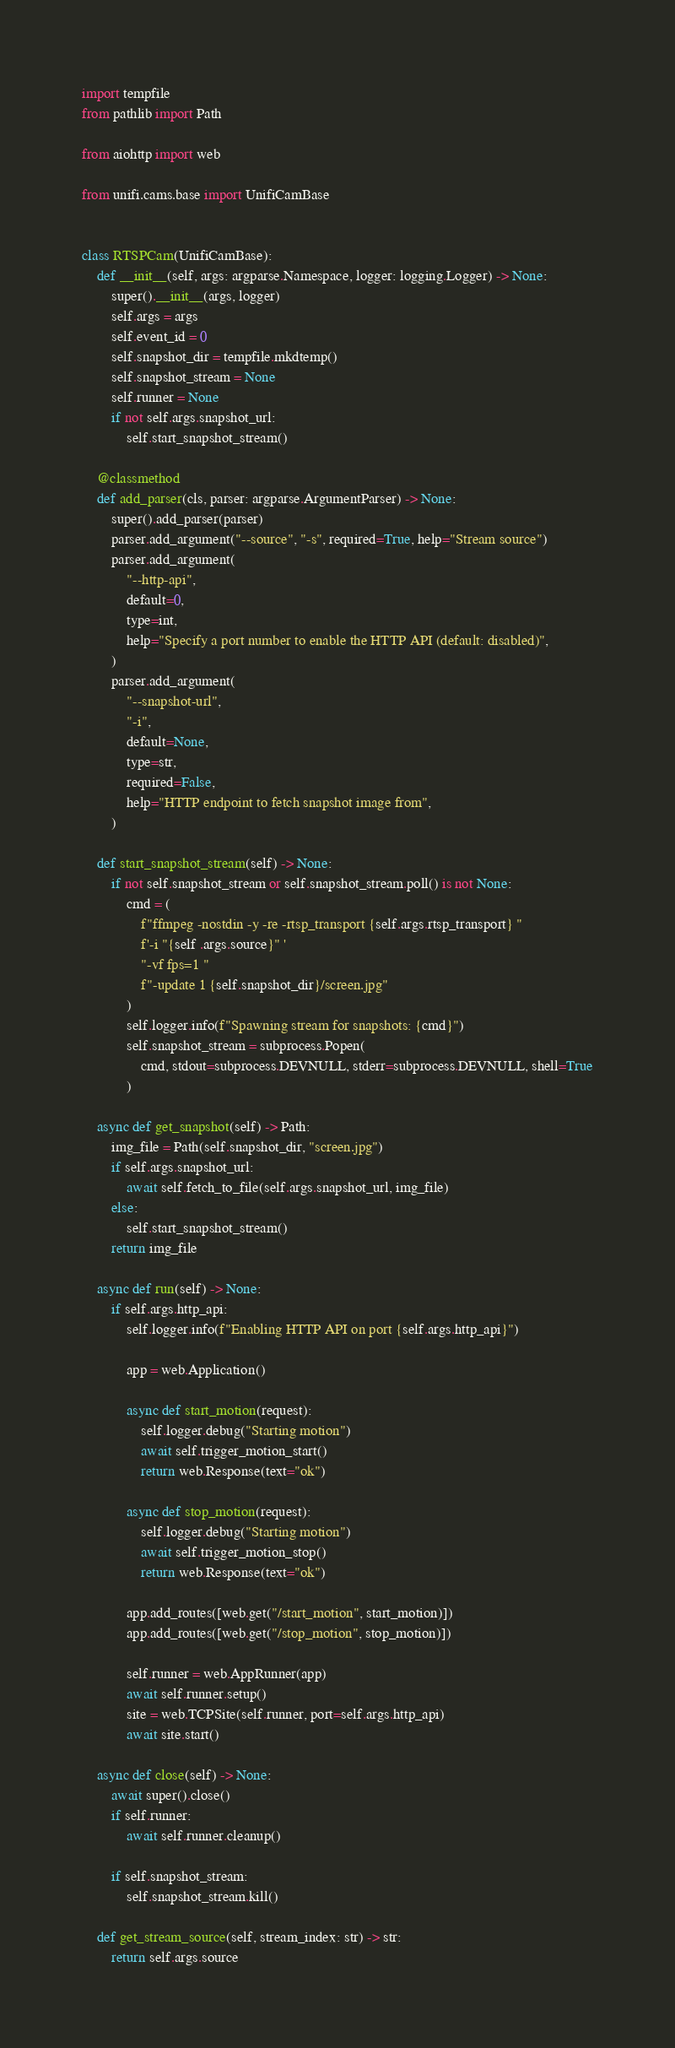Convert code to text. <code><loc_0><loc_0><loc_500><loc_500><_Python_>import tempfile
from pathlib import Path

from aiohttp import web

from unifi.cams.base import UnifiCamBase


class RTSPCam(UnifiCamBase):
    def __init__(self, args: argparse.Namespace, logger: logging.Logger) -> None:
        super().__init__(args, logger)
        self.args = args
        self.event_id = 0
        self.snapshot_dir = tempfile.mkdtemp()
        self.snapshot_stream = None
        self.runner = None
        if not self.args.snapshot_url:
            self.start_snapshot_stream()

    @classmethod
    def add_parser(cls, parser: argparse.ArgumentParser) -> None:
        super().add_parser(parser)
        parser.add_argument("--source", "-s", required=True, help="Stream source")
        parser.add_argument(
            "--http-api",
            default=0,
            type=int,
            help="Specify a port number to enable the HTTP API (default: disabled)",
        )
        parser.add_argument(
            "--snapshot-url",
            "-i",
            default=None,
            type=str,
            required=False,
            help="HTTP endpoint to fetch snapshot image from",
        )

    def start_snapshot_stream(self) -> None:
        if not self.snapshot_stream or self.snapshot_stream.poll() is not None:
            cmd = (
                f"ffmpeg -nostdin -y -re -rtsp_transport {self.args.rtsp_transport} "
                f'-i "{self .args.source}" '
                "-vf fps=1 "
                f"-update 1 {self.snapshot_dir}/screen.jpg"
            )
            self.logger.info(f"Spawning stream for snapshots: {cmd}")
            self.snapshot_stream = subprocess.Popen(
                cmd, stdout=subprocess.DEVNULL, stderr=subprocess.DEVNULL, shell=True
            )

    async def get_snapshot(self) -> Path:
        img_file = Path(self.snapshot_dir, "screen.jpg")
        if self.args.snapshot_url:
            await self.fetch_to_file(self.args.snapshot_url, img_file)
        else:
            self.start_snapshot_stream()
        return img_file

    async def run(self) -> None:
        if self.args.http_api:
            self.logger.info(f"Enabling HTTP API on port {self.args.http_api}")

            app = web.Application()

            async def start_motion(request):
                self.logger.debug("Starting motion")
                await self.trigger_motion_start()
                return web.Response(text="ok")

            async def stop_motion(request):
                self.logger.debug("Starting motion")
                await self.trigger_motion_stop()
                return web.Response(text="ok")

            app.add_routes([web.get("/start_motion", start_motion)])
            app.add_routes([web.get("/stop_motion", stop_motion)])

            self.runner = web.AppRunner(app)
            await self.runner.setup()
            site = web.TCPSite(self.runner, port=self.args.http_api)
            await site.start()

    async def close(self) -> None:
        await super().close()
        if self.runner:
            await self.runner.cleanup()

        if self.snapshot_stream:
            self.snapshot_stream.kill()

    def get_stream_source(self, stream_index: str) -> str:
        return self.args.source
</code> 